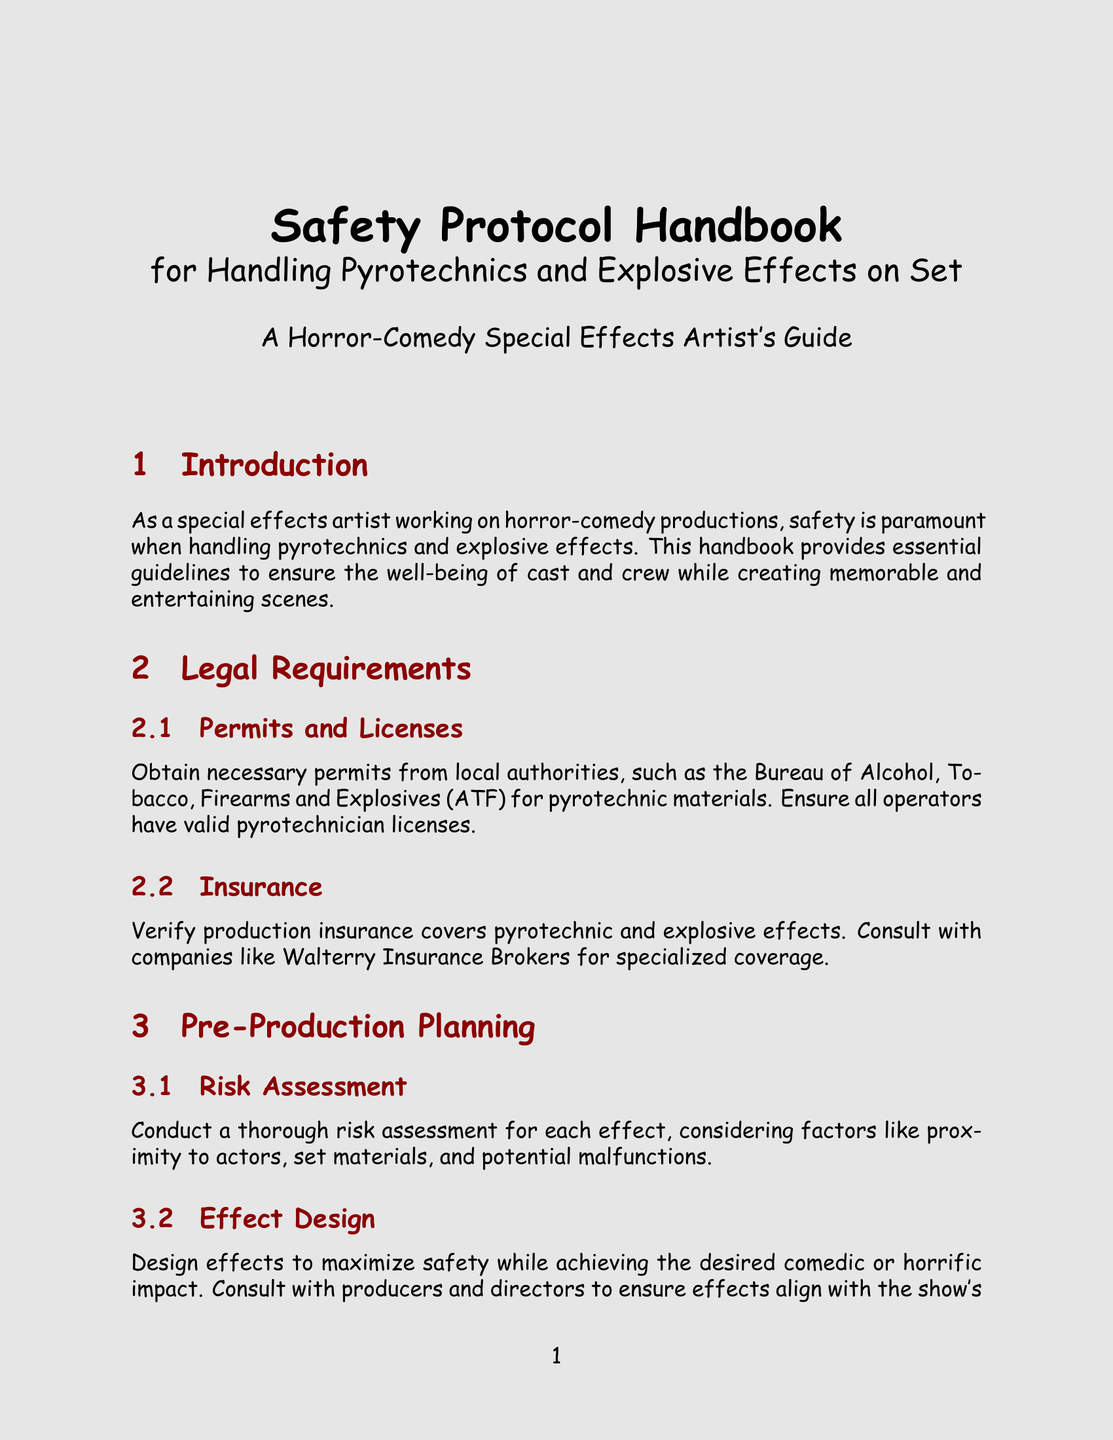what is the title of the document? The title of the document is provided at the beginning and specifies the purpose and focus on safety protocols.
Answer: Safety Protocol Handbook for Handling Pyrotechnics and Explosive Effects on Set who should be consulted for production insurance? The document advises to consult specific companies for specialized insurance coverage.
Answer: Walterry Insurance Brokers what type of protective clothing is recommended? The document lists types of personal protective equipment necessary for safety during pyrotechnic handling.
Answer: fire-resistant clothing what must be done before each effect is conducted? A crucial step outlined in the document involves assessing potential risks associated with effects before production.
Answer: conduct a thorough risk assessment what must be maintained on set for emergencies? The document emphasizes the necessity for a specific item to ensure first aid readiness on set.
Answer: fully stocked first aid kit which company provides water-based fog machines? The document names manufacturers of equipment that contribute to safer atmospheric effects.
Answer: CHAUVET DJ what must be labeled when storing pyrotechnic materials? The document states the requirement regarding the organization and marking of materials in storage.
Answer: clearly labeled what type of fire extinguishers should be kept available? The document specifies the category of fire extinguisher recommended for safety measures on set.
Answer: ABC type what action is required for unused materials and debris after production? The document outlines a post-production procedural step regarding leftover materials.
Answer: Properly dispose of unused materials and debris 